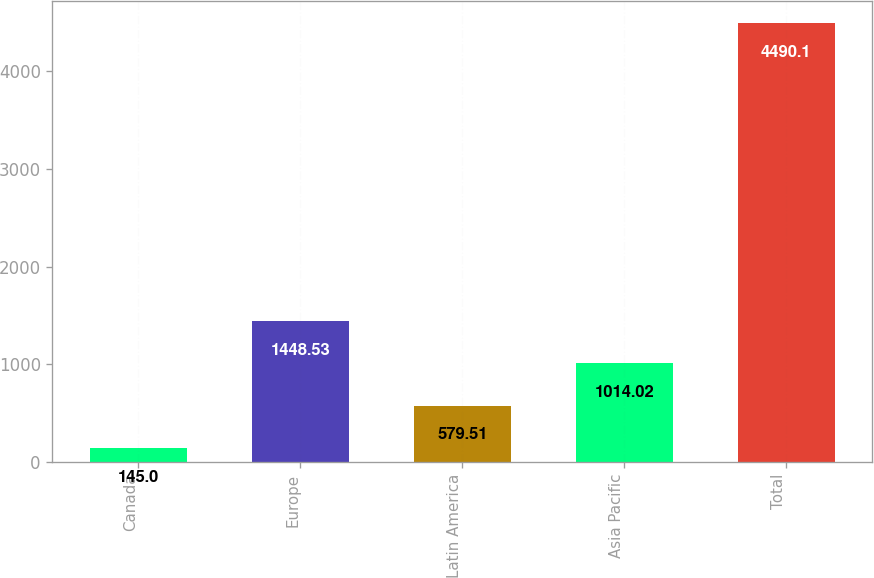<chart> <loc_0><loc_0><loc_500><loc_500><bar_chart><fcel>Canada<fcel>Europe<fcel>Latin America<fcel>Asia Pacific<fcel>Total<nl><fcel>145<fcel>1448.53<fcel>579.51<fcel>1014.02<fcel>4490.1<nl></chart> 